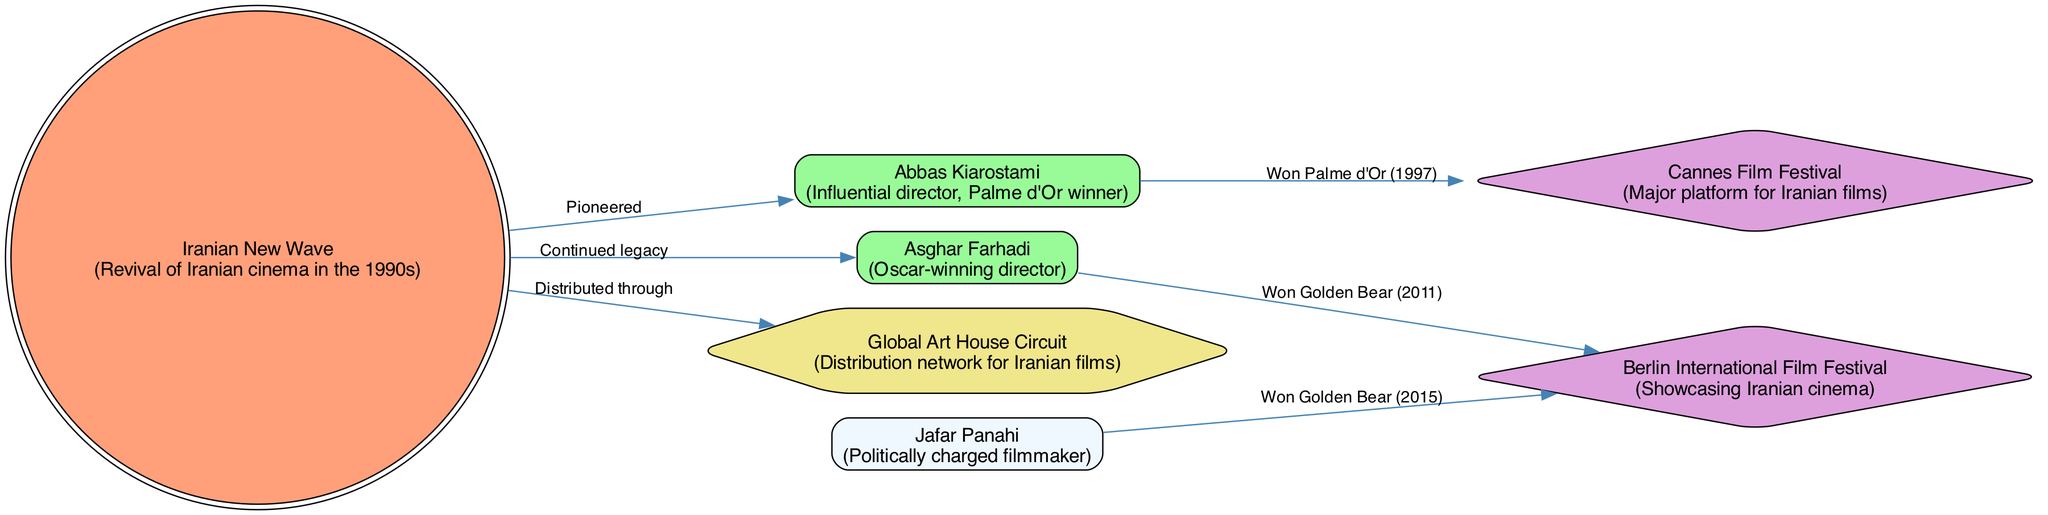What is the primary focus of the diagram? The diagram visually represents the global distribution and impact of Iranian cinema from the 1990s to the present day, illustrating the connections between key figures, festivals, and the Iranian New Wave.
Answer: Global distribution and impact of Iranian cinema How many nodes are present in the diagram? By counting the number of items listed within the "nodes" section of the data, we find that there are 7 distinct nodes representing various aspects of Iranian cinema.
Answer: 7 Who is the director associated with the Cannes Film Festival? From the map, Abbas Kiarostami is connected to the Cannes Film Festival with the edge labeled "Won Palme d'Or (1997)", showing his association with this prestigious event.
Answer: Abbas Kiarostami Which event did Asghar Farhadi win an award at? The diagram indicates that Asghar Farhadi is connected to the Berlin International Film Festival, where he won the Golden Bear in 2011, highlighting his achievement at this event.
Answer: Berlin International Film Festival What does the edge labeled "Pioneered" signify? The edge labeled "Pioneered" connects the "Iranian New Wave" to "Abbas Kiarostami", indicating that Kiarostami played a pioneering role in the revival of Iranian cinema during this movement.
Answer: Pioneered How many awards have been won by the directors listed? The diagram shows two awards won by directors: Abbas Kiarostami (Palme d'Or) and Asghar Farhadi (Golden Bear), and Jafar Panahi also won a Golden Bear. Therefore, three awards can be accounted for among these directors.
Answer: 3 Which filmmaker is described as a "Politically charged filmmaker"? The diagram highlights Jafar Panahi with the description "Politically charged filmmaker", indicating his notable stance and themes in film making.
Answer: Jafar Panahi What type of nodes are the film festivals in the diagram? The film festivals, Cannes Film Festival and Berlin International Film Festival, are represented as diamond-shaped nodes, indicating their importance and distinct nature within the network of Iranian cinema.
Answer: Diamond-shaped Which node is connected to the "Global Art House Circuit"? The "Iranian New Wave" node is connected to the "Global Art House Circuit" with the edge labeled "Distributed through", highlighting how films from this movement are distributed globally.
Answer: Iranian New Wave 